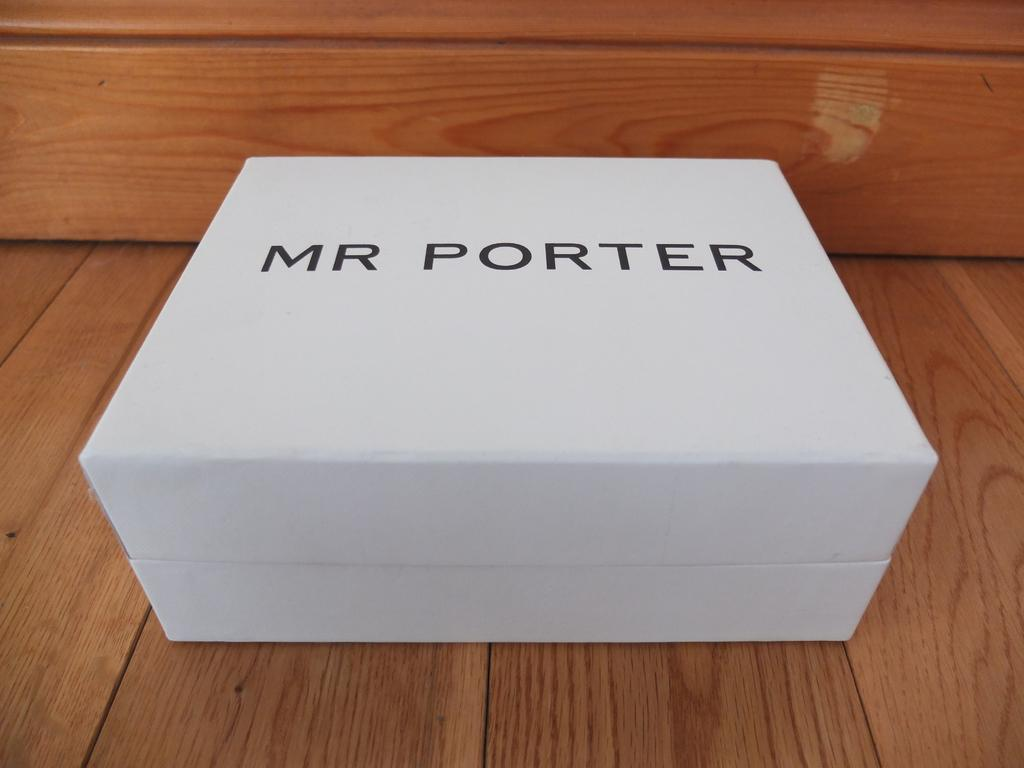<image>
Provide a brief description of the given image. White box with black letters printed Mr. Porter 